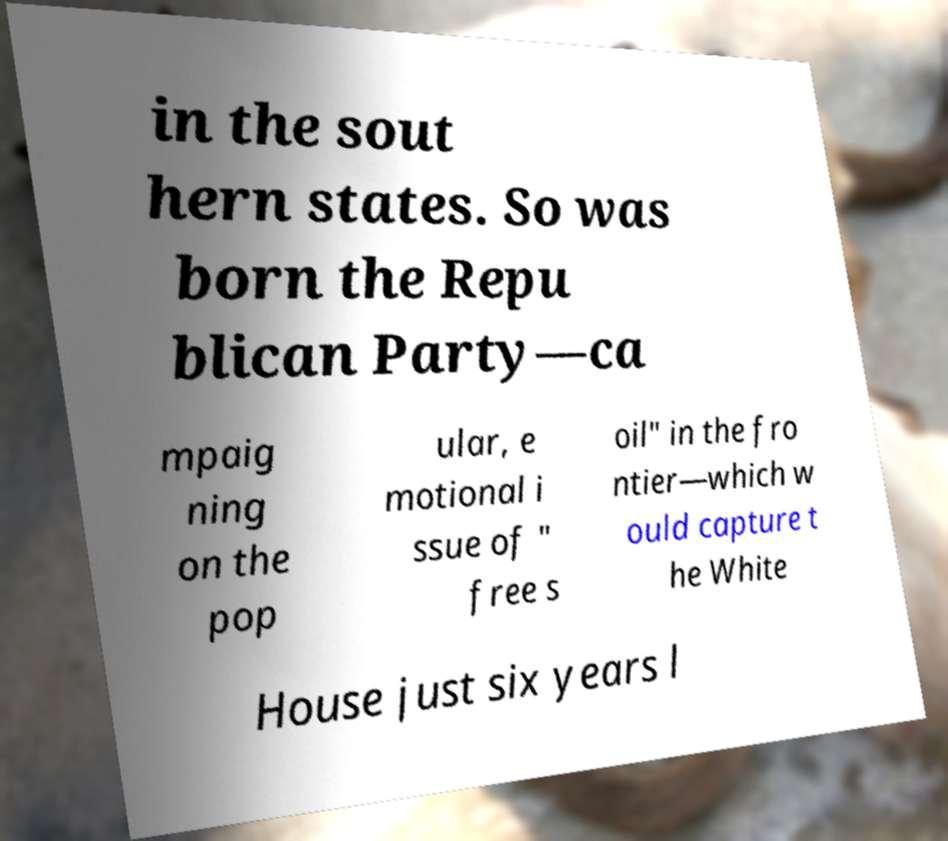Please identify and transcribe the text found in this image. in the sout hern states. So was born the Repu blican Party—ca mpaig ning on the pop ular, e motional i ssue of " free s oil" in the fro ntier—which w ould capture t he White House just six years l 